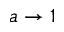<formula> <loc_0><loc_0><loc_500><loc_500>a \rightarrow 1</formula> 